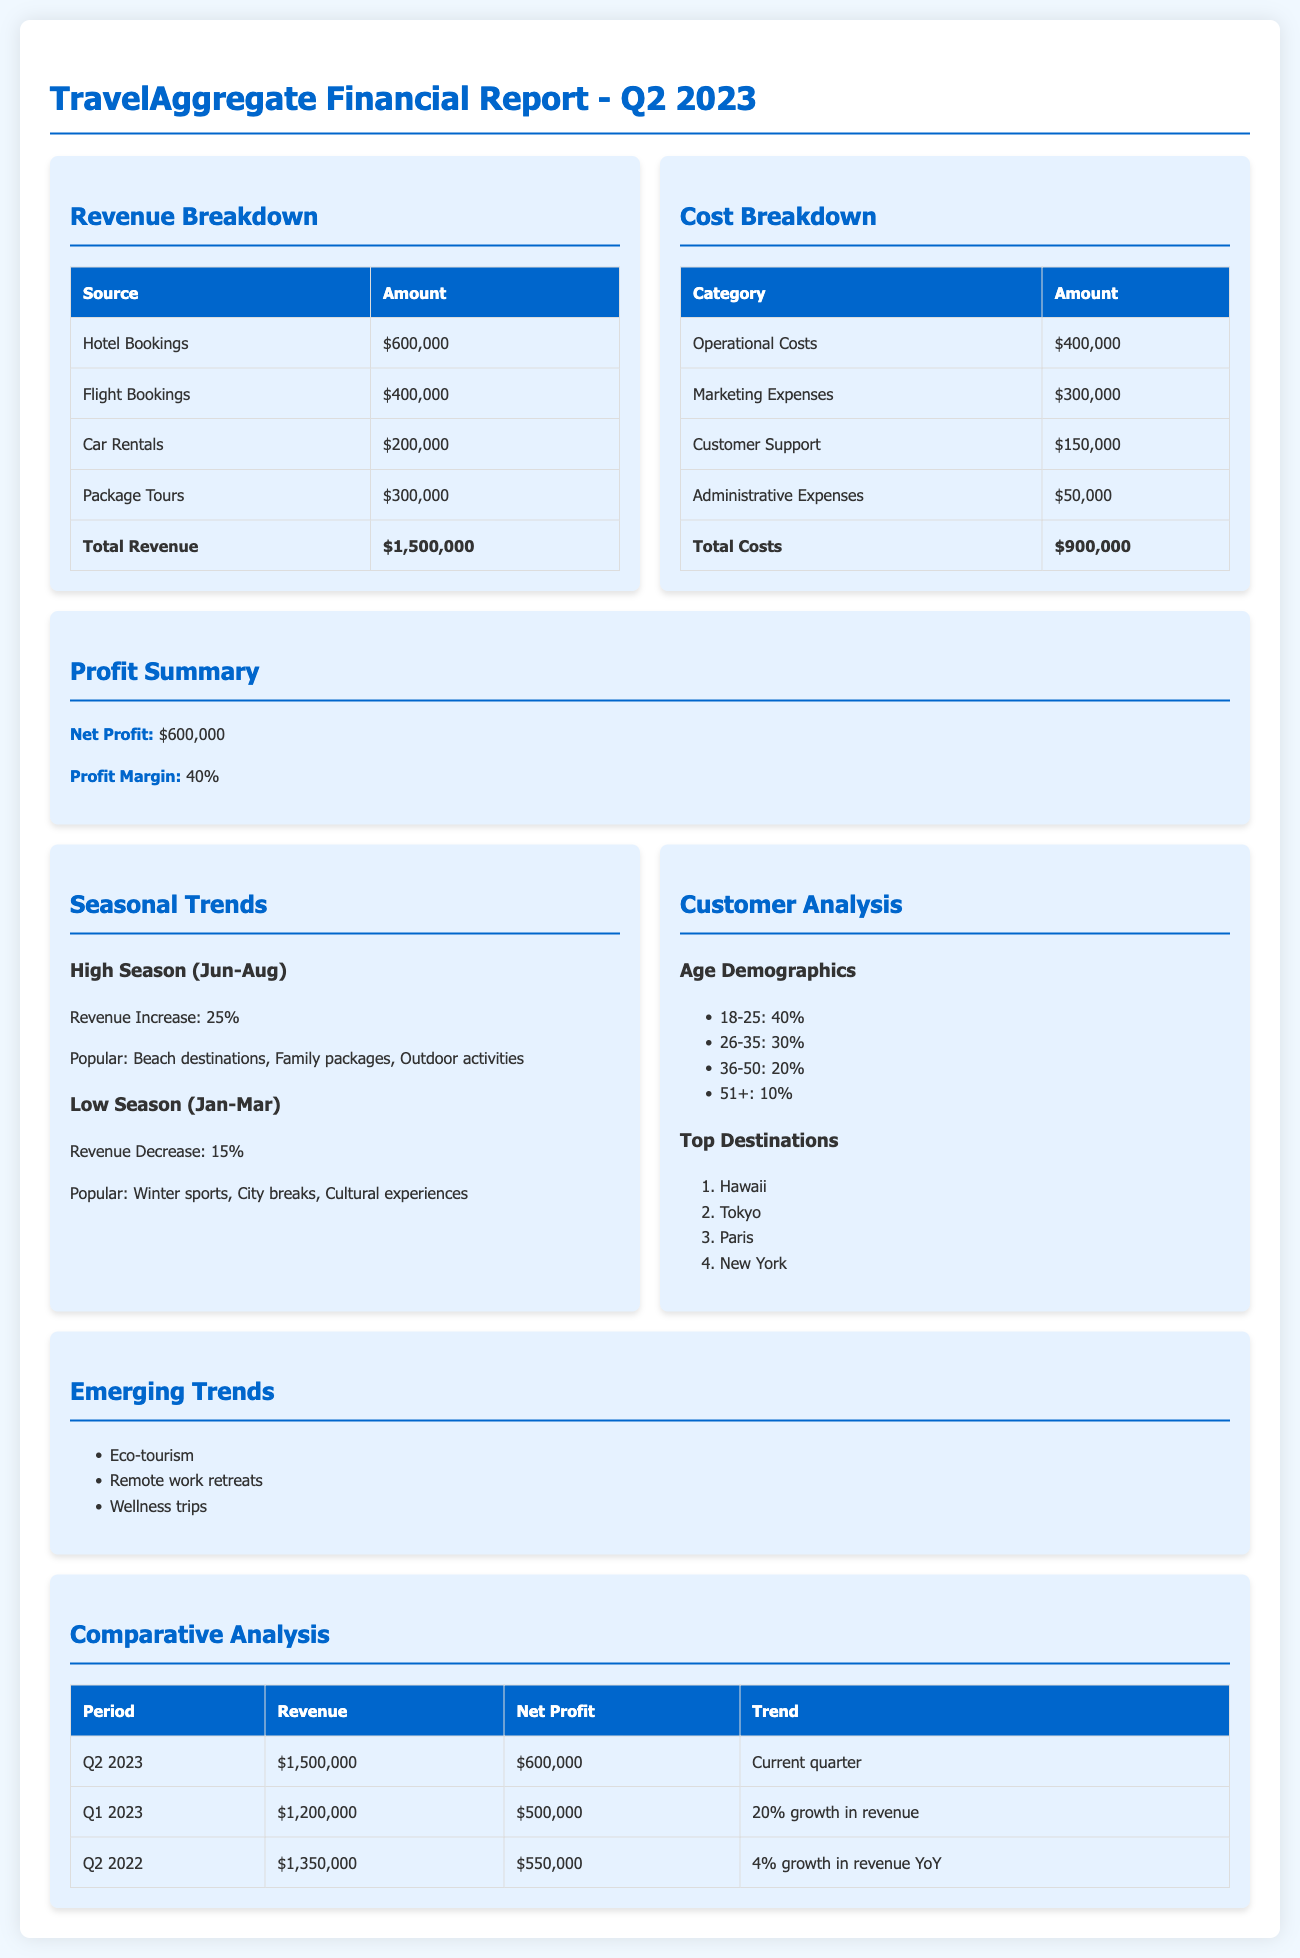what was the total revenue for Q2 2023? The total revenue is listed in the revenue breakdown section as $1,500,000.
Answer: $1,500,000 what is the net profit for Q2 2023? The net profit is stated in the profit summary section as $600,000.
Answer: $600,000 how much did the company spend on marketing expenses? The marketing expenses are detailed in the cost breakdown section as $300,000.
Answer: $300,000 what are the popular destinations during high season? The popular destinations listed during high season are beach destinations, family packages, and outdoor activities.
Answer: Beach destinations, family packages, outdoor activities what is the profit margin for Q2 2023? The profit margin is mentioned in the profit summary section as 40%.
Answer: 40% which age demographic had the highest percentage of customers? The age demographic with the highest percentage is 18-25, which accounts for 40%.
Answer: 18-25 how did Q2 2023 revenue compare to Q1 2023? The revenue comparison shows a 20% growth, with Q2 2023 at $1,500,000 and Q1 2023 at $1,200,000.
Answer: 20% growth what is one of the emerging trends mentioned in the report? The report mentions eco-tourism as one of the emerging trends.
Answer: Eco-tourism what was the total cost incurred in Q2 2023? The total cost is summarized in the cost breakdown section as $900,000.
Answer: $900,000 